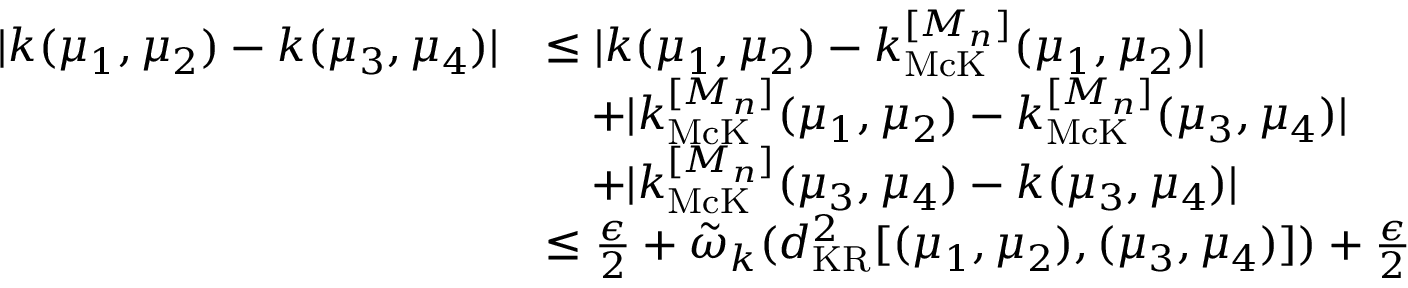Convert formula to latex. <formula><loc_0><loc_0><loc_500><loc_500>\begin{array} { r l } { | k ( \mu _ { 1 } , \mu _ { 2 } ) - k ( \mu _ { 3 } , \mu _ { 4 } ) | } & { \leq | k ( \mu _ { 1 } , \mu _ { 2 } ) - k _ { M c K } ^ { [ M _ { n } ] } ( \mu _ { 1 } , \mu _ { 2 } ) | } \\ & { \quad + | k _ { M c K } ^ { [ M _ { n } ] } ( \mu _ { 1 } , \mu _ { 2 } ) - k _ { M c K } ^ { [ M _ { n } ] } ( \mu _ { 3 } , \mu _ { 4 } ) | } \\ & { \quad + | k _ { M c K } ^ { [ M _ { n } ] } ( \mu _ { 3 } , \mu _ { 4 } ) - k ( \mu _ { 3 } , \mu _ { 4 } ) | } \\ & { \leq \frac { \epsilon } { 2 } + \tilde { \omega } _ { k } ( d _ { K R } ^ { 2 } [ ( \mu _ { 1 } , \mu _ { 2 } ) , ( \mu _ { 3 } , \mu _ { 4 } ) ] ) + \frac { \epsilon } { 2 } } \end{array}</formula> 